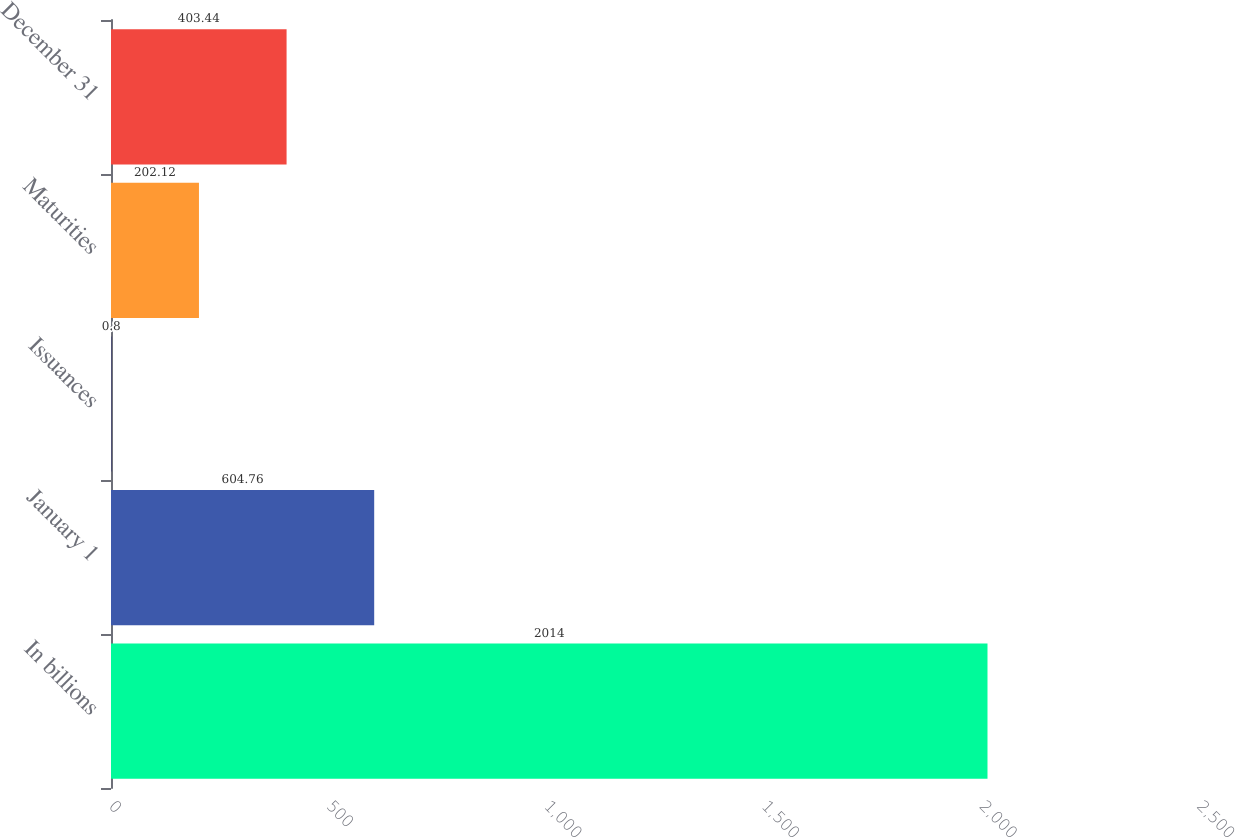Convert chart to OTSL. <chart><loc_0><loc_0><loc_500><loc_500><bar_chart><fcel>In billions<fcel>January 1<fcel>Issuances<fcel>Maturities<fcel>December 31<nl><fcel>2014<fcel>604.76<fcel>0.8<fcel>202.12<fcel>403.44<nl></chart> 